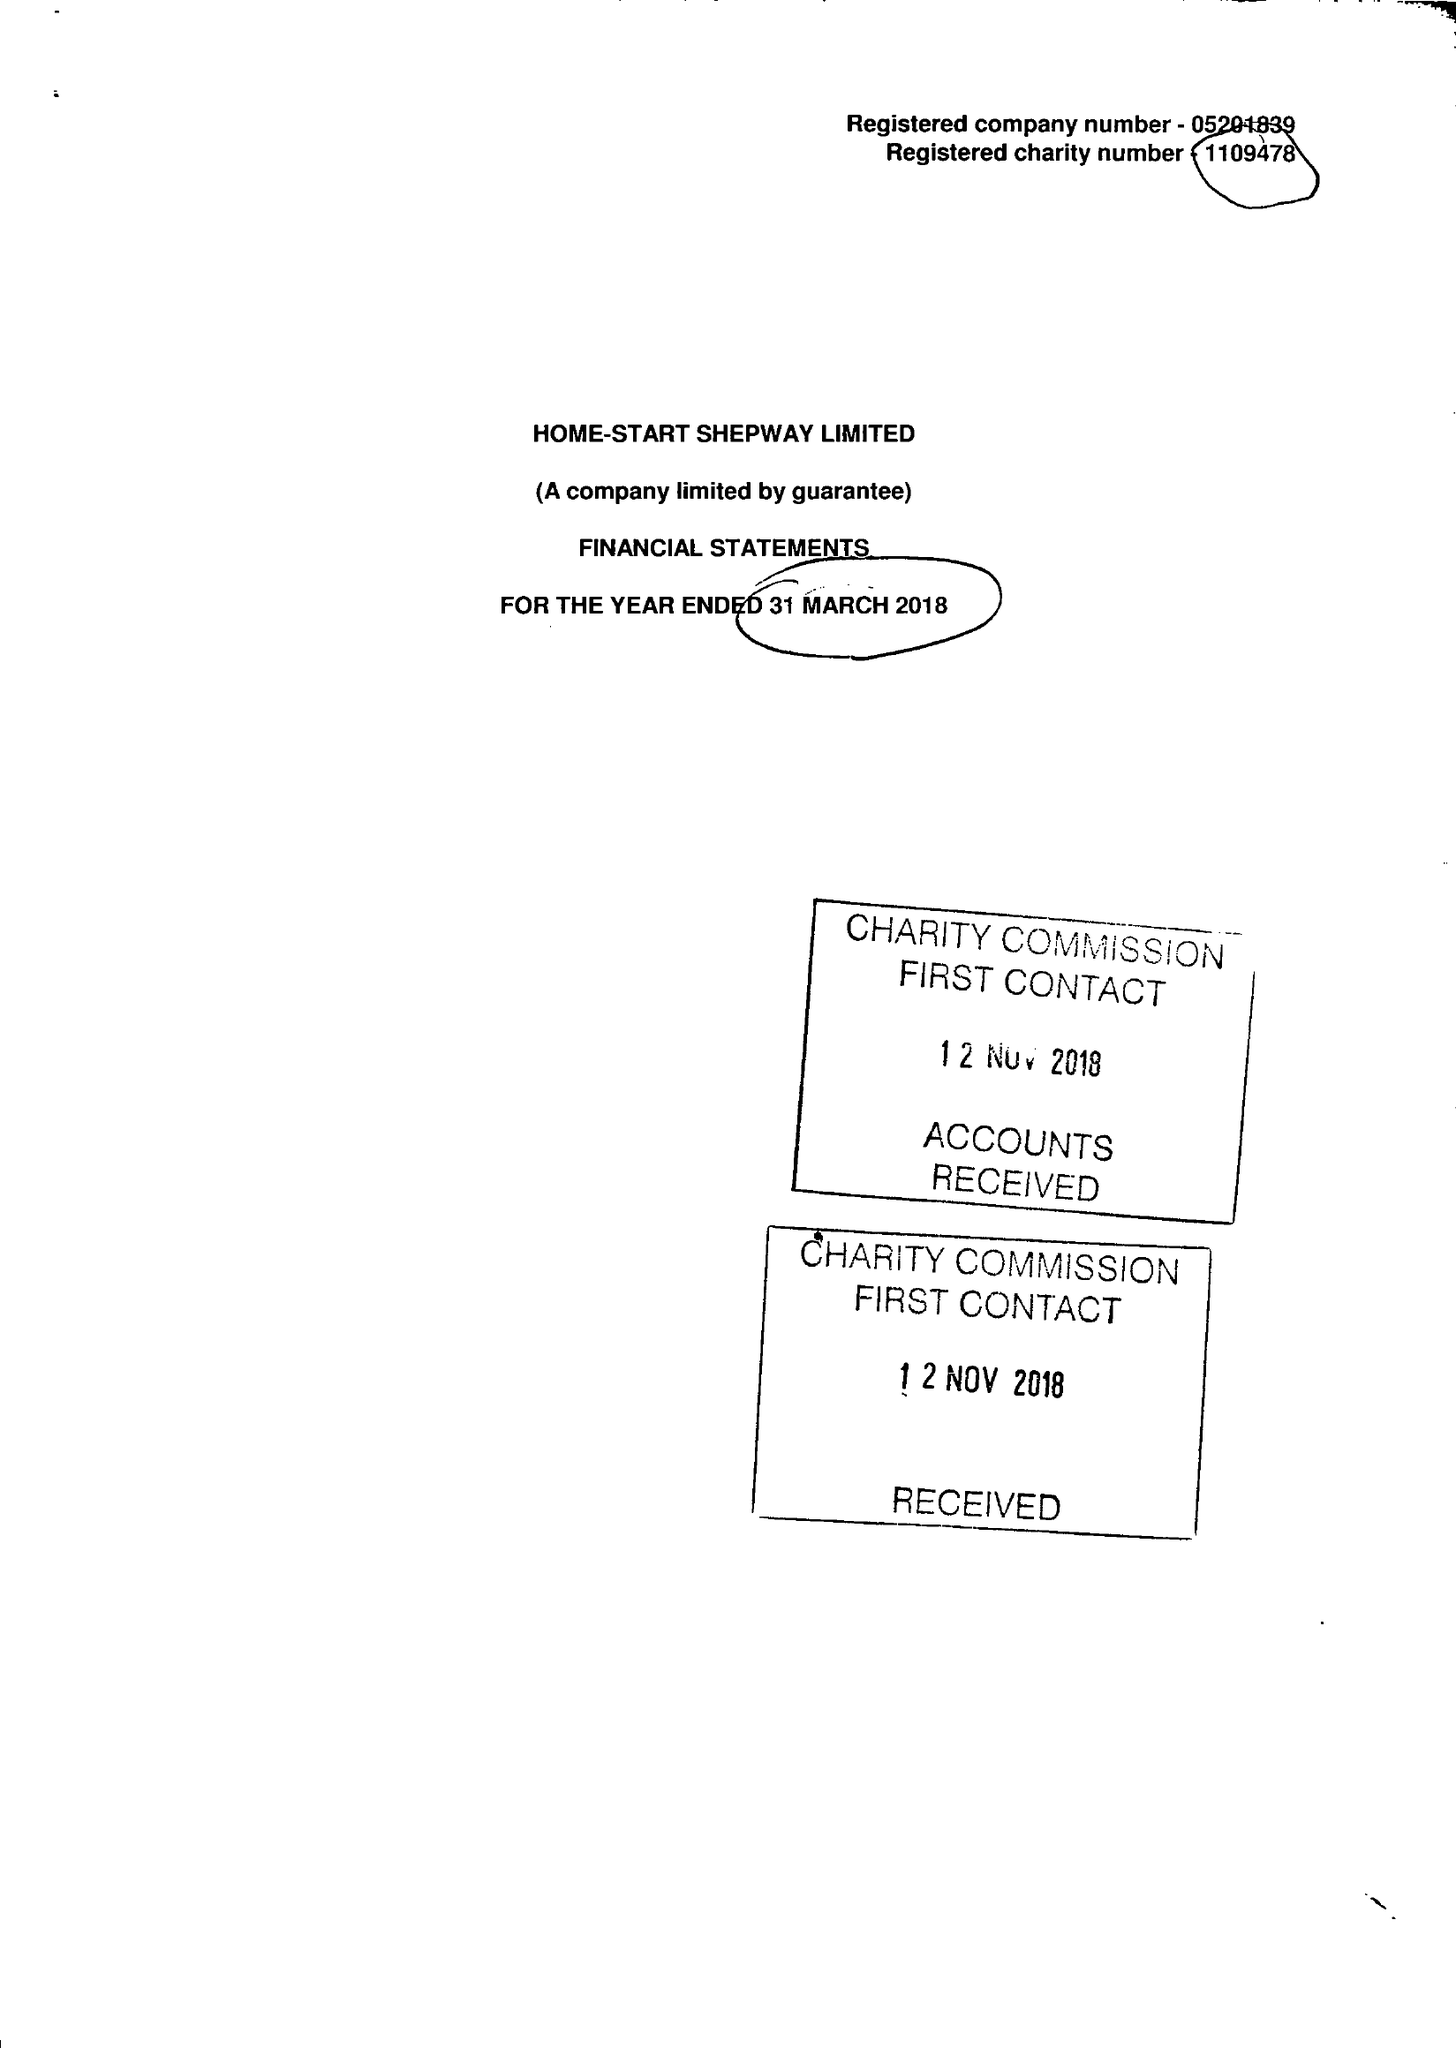What is the value for the charity_number?
Answer the question using a single word or phrase. 1109478 